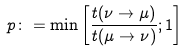<formula> <loc_0><loc_0><loc_500><loc_500>p \colon = \min \left [ \frac { t ( \nu \rightarrow \mu ) } { t ( \mu \rightarrow \nu ) } ; 1 \right ]</formula> 